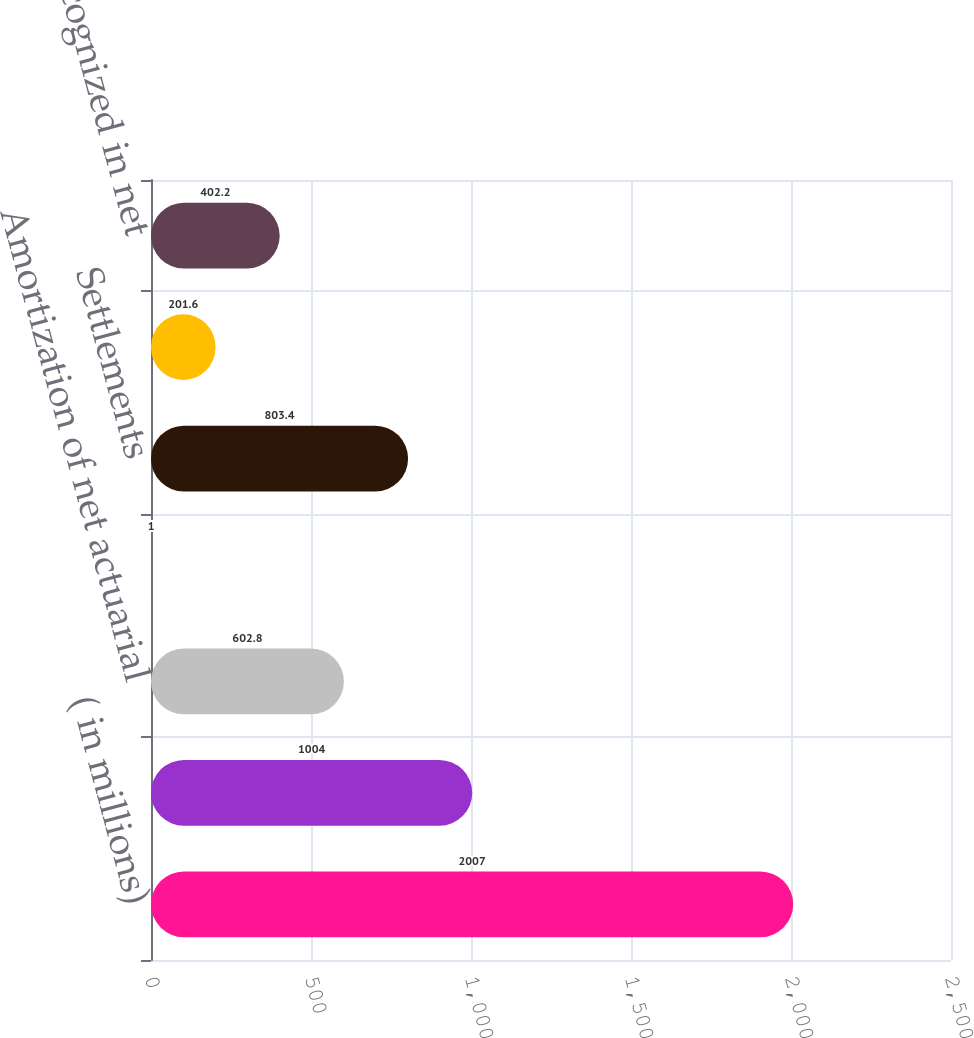Convert chart to OTSL. <chart><loc_0><loc_0><loc_500><loc_500><bar_chart><fcel>( in millions)<fcel>Net actuarial loss<fcel>Amortization of net actuarial<fcel>Amortization of prior service<fcel>Settlements<fcel>Total recognized in other<fcel>Total recognized in net<nl><fcel>2007<fcel>1004<fcel>602.8<fcel>1<fcel>803.4<fcel>201.6<fcel>402.2<nl></chart> 